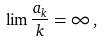<formula> <loc_0><loc_0><loc_500><loc_500>\lim \frac { a _ { k } } { k } = \infty \, ,</formula> 